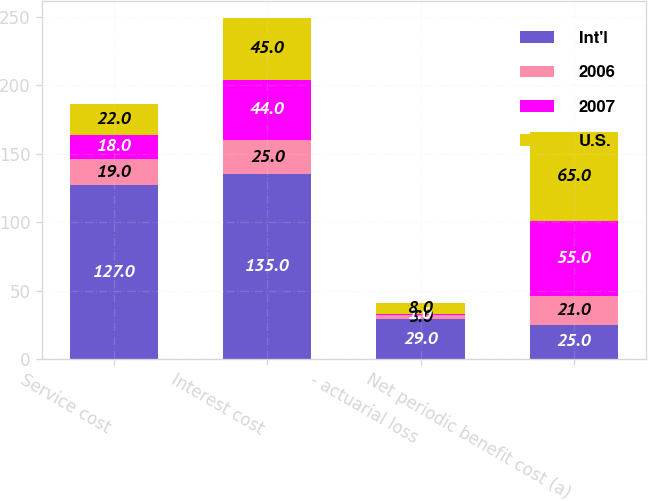<chart> <loc_0><loc_0><loc_500><loc_500><stacked_bar_chart><ecel><fcel>Service cost<fcel>Interest cost<fcel>- actuarial loss<fcel>Net periodic benefit cost (a)<nl><fcel>Int'l<fcel>127<fcel>135<fcel>29<fcel>25<nl><fcel>2006<fcel>19<fcel>25<fcel>3<fcel>21<nl><fcel>2007<fcel>18<fcel>44<fcel>1<fcel>55<nl><fcel>U.S.<fcel>22<fcel>45<fcel>8<fcel>65<nl></chart> 